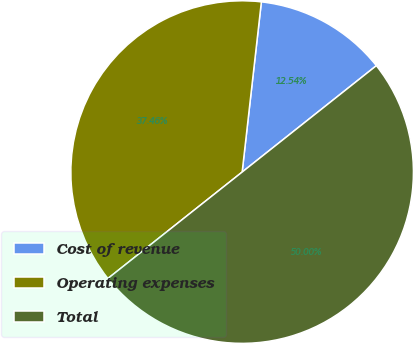<chart> <loc_0><loc_0><loc_500><loc_500><pie_chart><fcel>Cost of revenue<fcel>Operating expenses<fcel>Total<nl><fcel>12.54%<fcel>37.46%<fcel>50.0%<nl></chart> 